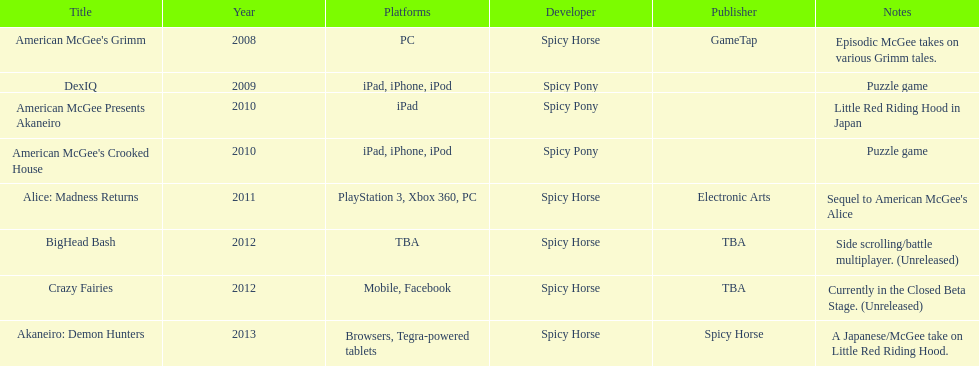What are all the names of the titles? American McGee's Grimm, DexIQ, American McGee Presents Akaneiro, American McGee's Crooked House, Alice: Madness Returns, BigHead Bash, Crazy Fairies, Akaneiro: Demon Hunters. Who issued each title? GameTap, , , , Electronic Arts, TBA, TBA, Spicy Horse. Which game was put out by electronic arts? Alice: Madness Returns. 